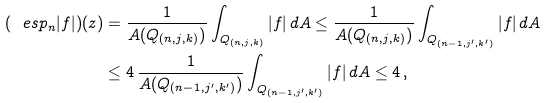Convert formula to latex. <formula><loc_0><loc_0><loc_500><loc_500>( \ e s p _ { n } | f | ) ( z ) & = \frac { 1 } { A ( Q _ { ( n , j , k ) } ) } \int _ { Q _ { ( n , j , k ) } } | f | \, d A \leq \frac { 1 } { A ( Q _ { ( n , j , k ) } ) } \int _ { Q _ { ( n - 1 , j ^ { \prime } , k ^ { \prime } ) } } | f | \, d A \\ & \leq 4 \, \frac { 1 } { A ( Q _ { ( n - 1 , j ^ { \prime } , k ^ { \prime } ) } ) } \int _ { Q _ { ( n - 1 , j ^ { \prime } , k ^ { \prime } ) } } | f | \, d A \leq 4 \, ,</formula> 